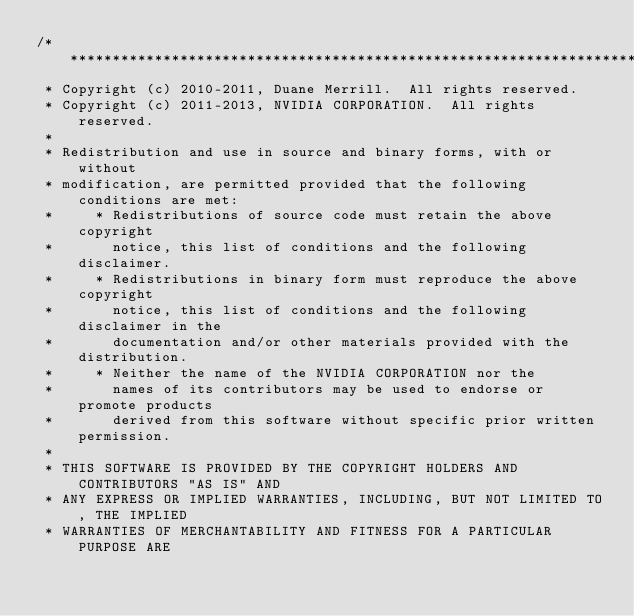Convert code to text. <code><loc_0><loc_0><loc_500><loc_500><_Cuda_>/******************************************************************************
 * Copyright (c) 2010-2011, Duane Merrill.  All rights reserved.
 * Copyright (c) 2011-2013, NVIDIA CORPORATION.  All rights reserved.
 * 
 * Redistribution and use in source and binary forms, with or without
 * modification, are permitted provided that the following conditions are met:
 *     * Redistributions of source code must retain the above copyright
 *       notice, this list of conditions and the following disclaimer.
 *     * Redistributions in binary form must reproduce the above copyright
 *       notice, this list of conditions and the following disclaimer in the
 *       documentation and/or other materials provided with the distribution.
 *     * Neither the name of the NVIDIA CORPORATION nor the
 *       names of its contributors may be used to endorse or promote products
 *       derived from this software without specific prior written permission.
 * 
 * THIS SOFTWARE IS PROVIDED BY THE COPYRIGHT HOLDERS AND CONTRIBUTORS "AS IS" AND
 * ANY EXPRESS OR IMPLIED WARRANTIES, INCLUDING, BUT NOT LIMITED TO, THE IMPLIED
 * WARRANTIES OF MERCHANTABILITY AND FITNESS FOR A PARTICULAR PURPOSE ARE</code> 